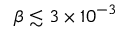Convert formula to latex. <formula><loc_0><loc_0><loc_500><loc_500>\beta \lesssim 3 \times 1 0 ^ { - 3 }</formula> 